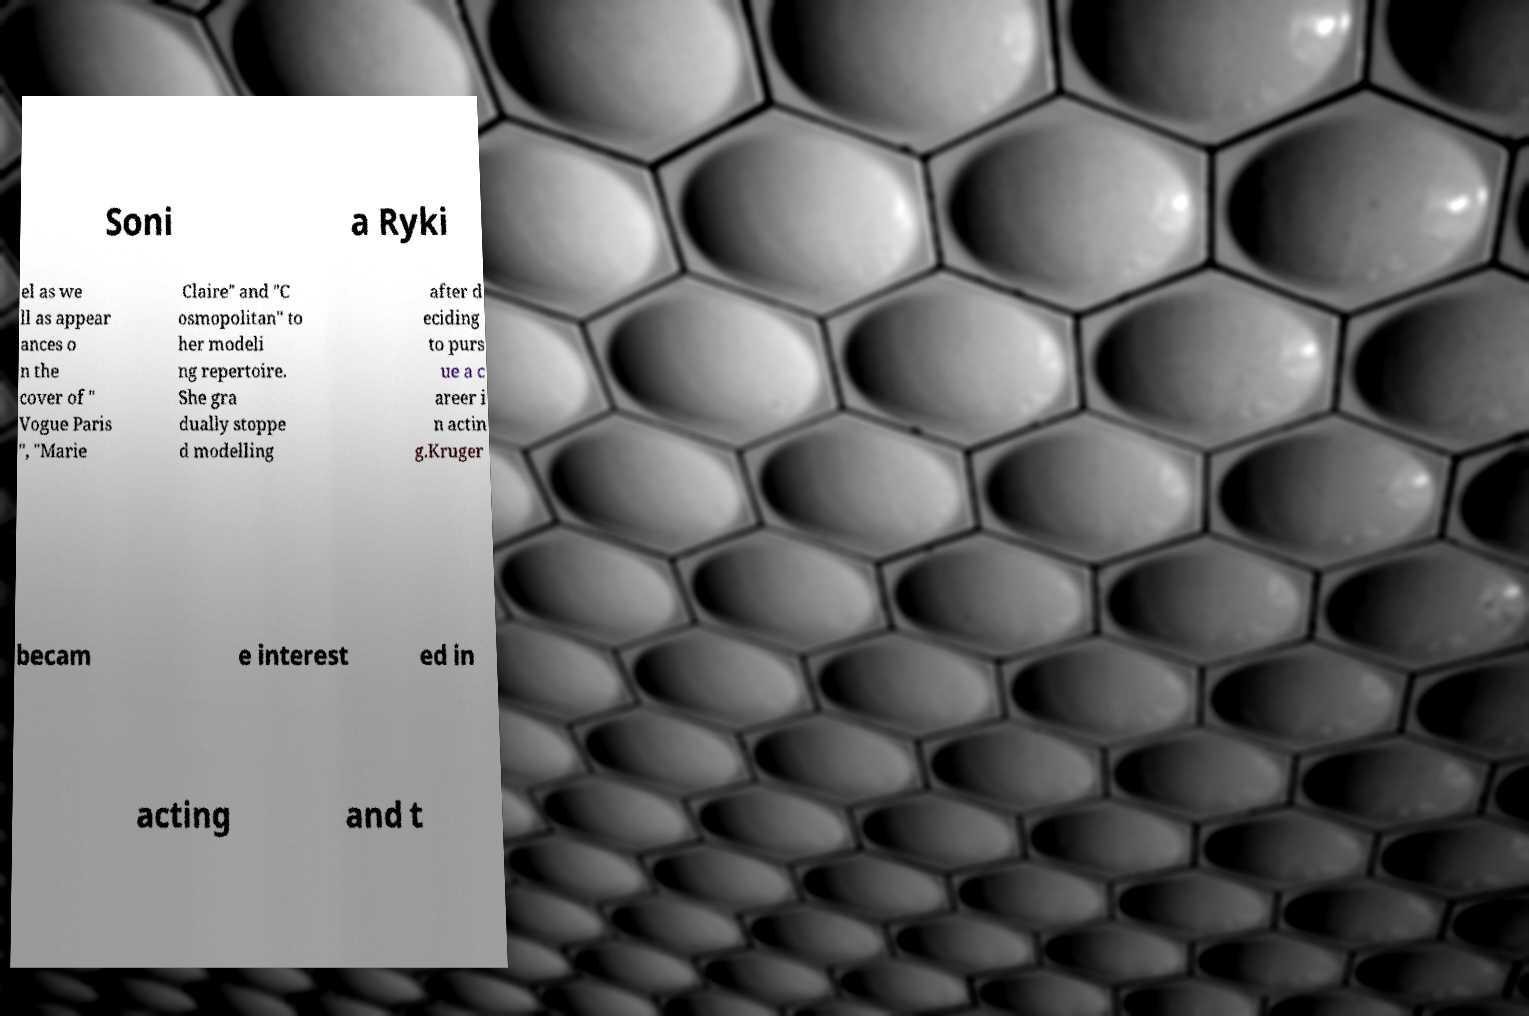What messages or text are displayed in this image? I need them in a readable, typed format. Soni a Ryki el as we ll as appear ances o n the cover of " Vogue Paris ", "Marie Claire" and "C osmopolitan" to her modeli ng repertoire. She gra dually stoppe d modelling after d eciding to purs ue a c areer i n actin g.Kruger becam e interest ed in acting and t 